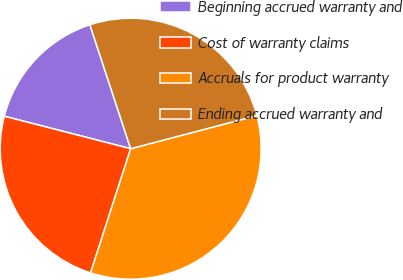Convert chart. <chart><loc_0><loc_0><loc_500><loc_500><pie_chart><fcel>Beginning accrued warranty and<fcel>Cost of warranty claims<fcel>Accruals for product warranty<fcel>Ending accrued warranty and<nl><fcel>15.94%<fcel>24.03%<fcel>34.06%<fcel>25.97%<nl></chart> 